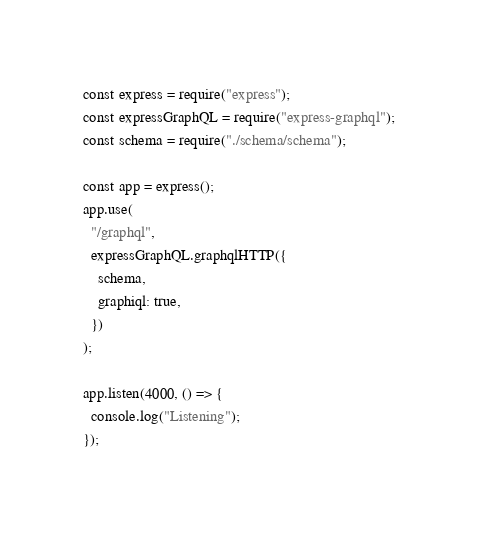Convert code to text. <code><loc_0><loc_0><loc_500><loc_500><_JavaScript_>const express = require("express");
const expressGraphQL = require("express-graphql");
const schema = require("./schema/schema");

const app = express();
app.use(
  "/graphql",
  expressGraphQL.graphqlHTTP({
    schema,
    graphiql: true,
  })
);

app.listen(4000, () => {
  console.log("Listening");
});
</code> 